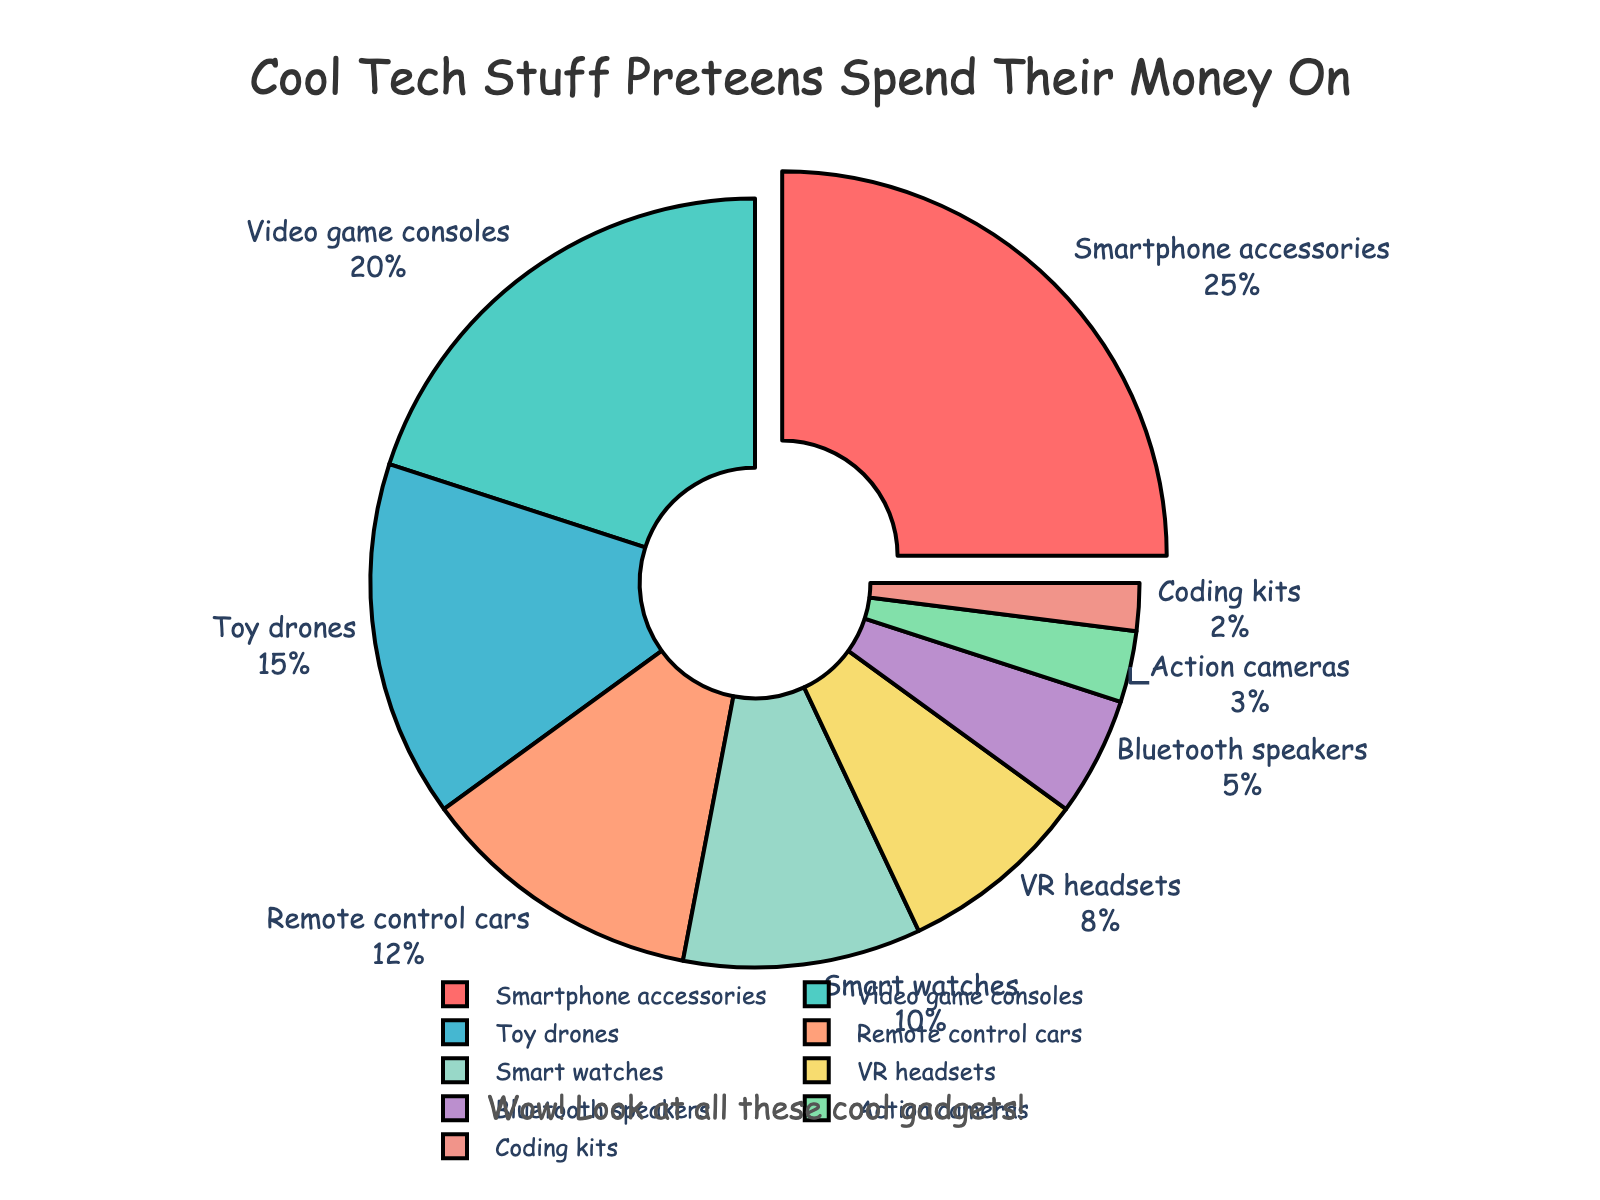What is the most popular tech item preteens spend their allowance on? The slice that is pulled out of the pie chart and has the highest percentage represents the most popular tech item. The "Smartphone accessories" slice is 25%.
Answer: Smartphone accessories Which category has the smallest percentage of spending? The smallest slice corresponds to the smallest percentage. The "Coding kits" slice is the smallest with 2%.
Answer: Coding kits How much more is spent on video game consoles compared to smart watches? The percentage for video game consoles is 20%, and for smart watches, it is 10%. Subtract 10% from 20%.
Answer: 10% What is the combined percentage spent on toy drones and remote control cars? Add the percentages for both categories. Toy drones: 15% + Remote control cars: 12%. 15% + 12% = 27%.
Answer: 27% Which category is associated with a light blue color? The slice with 8% corresponds to the VR headsets category, which is colored light blue.
Answer: VR headsets Are action cameras more or less popular than Bluetooth speakers in spending? Compare the percentages of action cameras (3%) and Bluetooth speakers (5%). Since 3% is less than 5%, action cameras are less popular.
Answer: Less popular Which two categories combined have a total of 18% spending? Look for categories whose percentages add up to 18%. Action cameras (3%) and Bluetooth speakers (5%) add up to 8%, which is too low. Remote control cars (12%) and VR headsets (8%) add up to 20%, which is too high. Smart watches (10%) and Bluetooth speakers (5%) add up to 15%, which is close but not correct. The appropriate combination is remote control cars (12%) and coding kits (2%) which sum to 14%, thus slightly less
Answer: Remote control cars and coding kits What percentage more of allowance is spent on toy drones than action cameras? The percentage for toy drones is 15% and for action cameras is 3%. Subtract 3% from 15%.
Answer: 12% Which category occupies the second largest share of the pie chart? The second-largest slice after the largest one is for video game consoles, which is 20%.
Answer: Video game consoles 